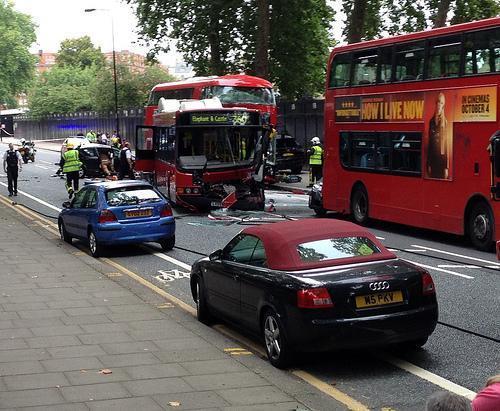How many trucks are crushing on the street?
Give a very brief answer. 1. 